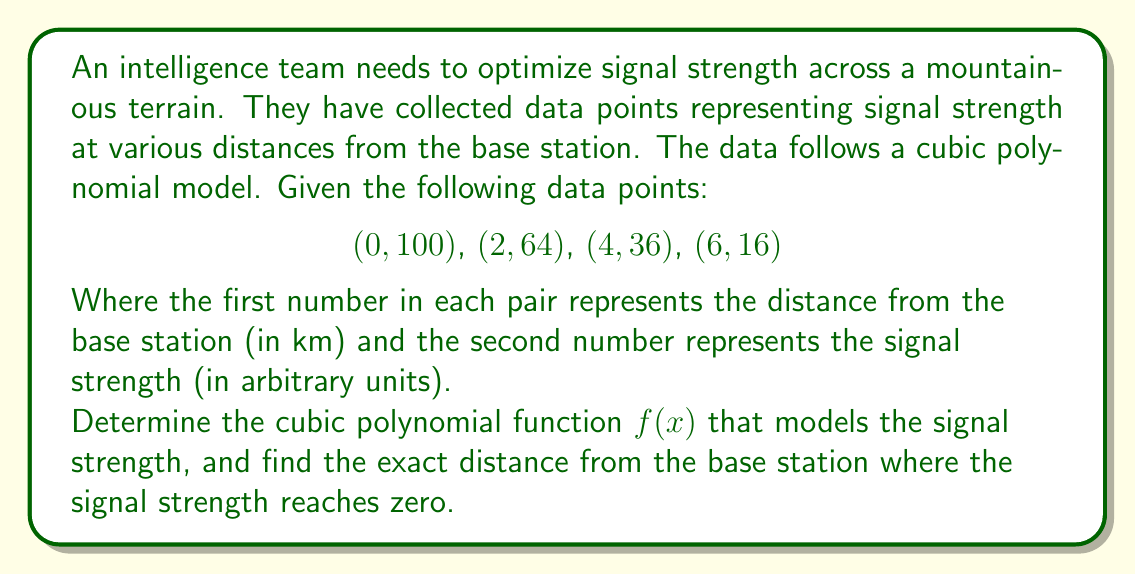Solve this math problem. 1) For a cubic polynomial $f(x) = ax^3 + bx^2 + cx + d$, we need to solve for a, b, c, and d.

2) Substituting the given points into the equation:

   100 = a(0)^3 + b(0)^2 + c(0) + d
   64 = a(2)^3 + b(2)^2 + c(2) + d
   36 = a(4)^3 + b(4)^2 + c(4) + d
   16 = a(6)^3 + b(6)^2 + c(6) + d

3) Simplifying:

   100 = d
   64 = 8a + 4b + 2c + 100
   36 = 64a + 16b + 4c + 100
   16 = 216a + 36b + 6c + 100

4) Subtracting 100 from each equation:

   0 = 0
   -36 = 8a + 4b + 2c
   -64 = 64a + 16b + 4c
   -84 = 216a + 36b + 6c

5) Using elimination method to solve this system of equations:

   a = -1
   b = 6
   c = -14
   d = 100

6) Therefore, the cubic polynomial function is:

   $f(x) = -x^3 + 6x^2 - 14x + 100$

7) To find where the signal strength reaches zero, solve:

   $-x^3 + 6x^2 - 14x + 100 = 0$

8) This can be factored as:

   $(x - 10)(x^2 + 4x - 10) = 0$

9) Solving this equation:

   $x = 10$ or $x = \frac{-4 \pm \sqrt{16 + 40}}{2} = \frac{-4 \pm \sqrt{56}}{2}$

10) The positive solution from the quadratic formula is approximately 2.74, which is less than 10. Therefore, the signal strength first reaches zero at x = 10.
Answer: 10 km 